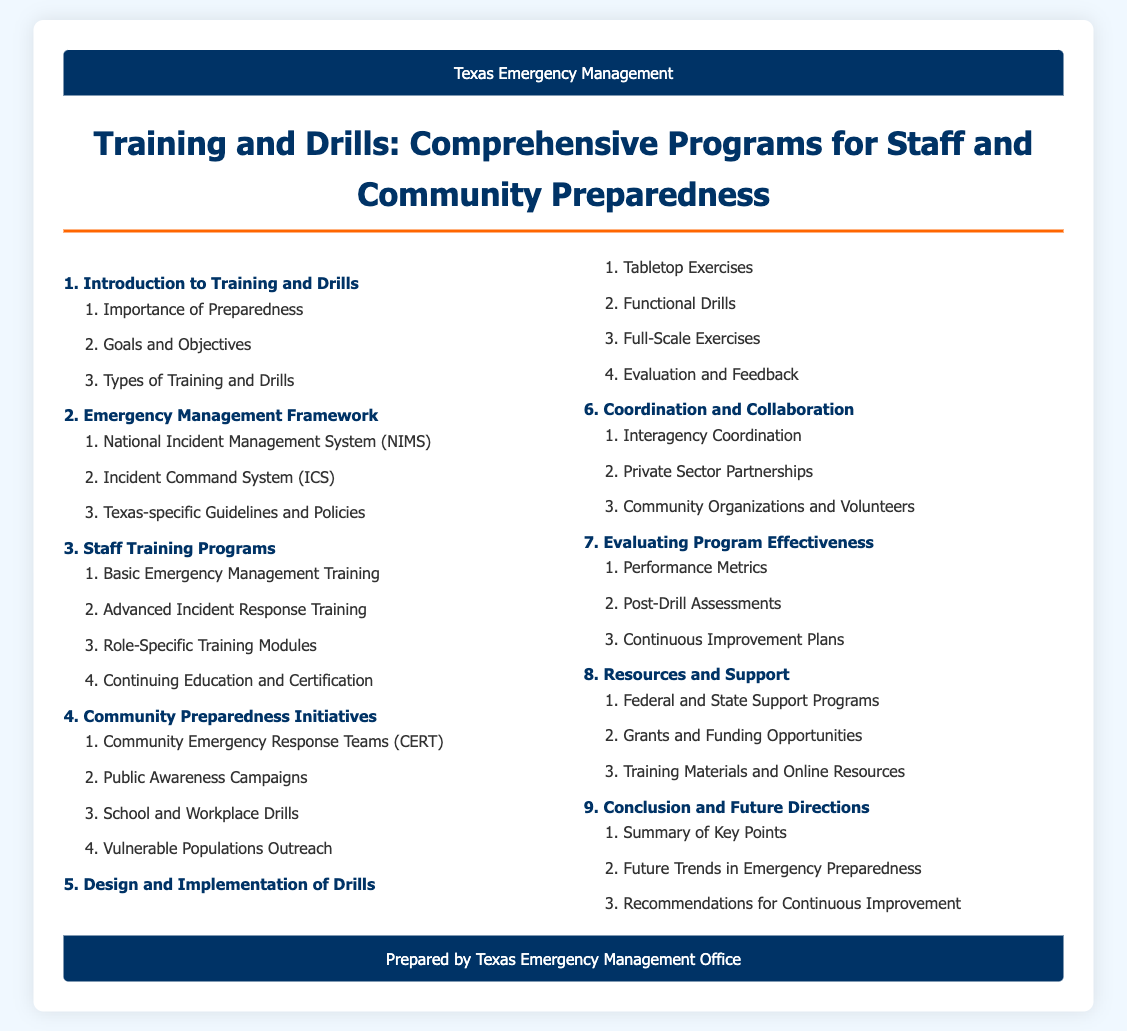What is the first main section of the document? The first main section listed in the table of contents is "Introduction to Training and Drills."
Answer: Introduction to Training and Drills How many types of training and drills are mentioned? There are three types of training and drills mentioned under the "Types of Training and Drills" subsection.
Answer: 3 What is the purpose of Community Emergency Response Teams? Community Emergency Response Teams are designed for community preparedness and response.
Answer: Community preparedness and response Which training program focuses on advanced skills? The training program specifically for advanced skills is titled "Advanced Incident Response Training."
Answer: Advanced Incident Response Training What are the two main areas focused on in the last section of the document? The last section covers "Summary of Key Points" and "Future Trends in Emergency Preparedness."
Answer: Summary of Key Points and Future Trends in Emergency Preparedness What kind of exercises are included in the "Design and Implementation of Drills" section? The section includes "Tabletop Exercises," "Functional Drills," and "Full-Scale Exercises."
Answer: Tabletop Exercises, Functional Drills, and Full-Scale Exercises Which organization supports the grants and funding opportunities listed? The organization providing support is likely federal and state programs as indicated in the document.
Answer: Federal and State Support Programs 